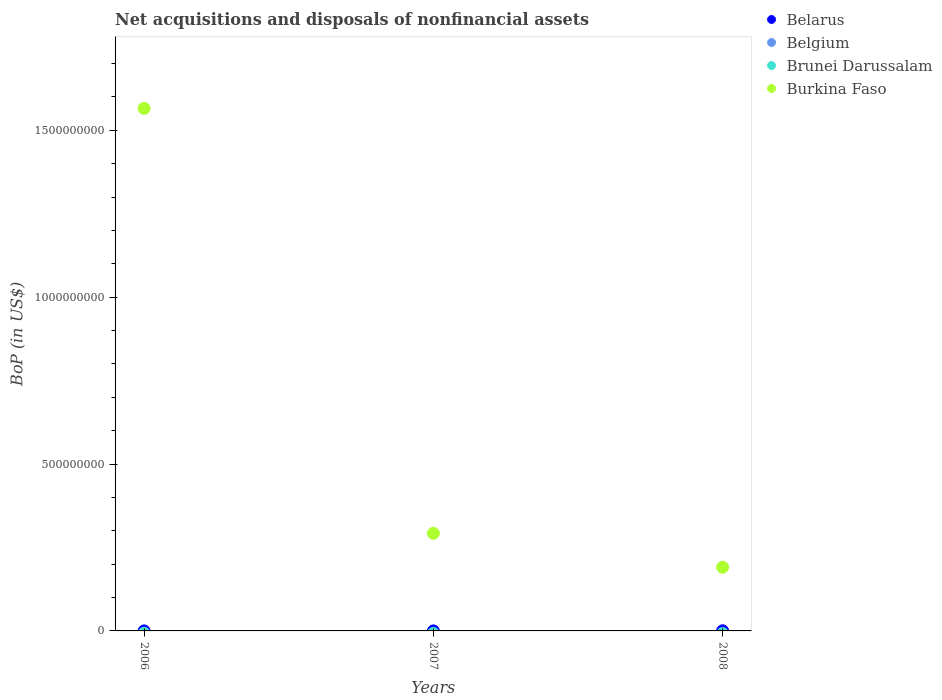Is the number of dotlines equal to the number of legend labels?
Provide a succinct answer. No. What is the Balance of Payments in Brunei Darussalam in 2008?
Your answer should be very brief. 0. Across all years, what is the maximum Balance of Payments in Burkina Faso?
Provide a succinct answer. 1.57e+09. What is the total Balance of Payments in Burkina Faso in the graph?
Your response must be concise. 2.05e+09. What is the difference between the Balance of Payments in Burkina Faso in 2007 and that in 2008?
Provide a succinct answer. 1.02e+08. What is the difference between the Balance of Payments in Burkina Faso in 2006 and the Balance of Payments in Belarus in 2007?
Give a very brief answer. 1.57e+09. What is the average Balance of Payments in Burkina Faso per year?
Ensure brevity in your answer.  6.83e+08. In the year 2006, what is the difference between the Balance of Payments in Burkina Faso and Balance of Payments in Belarus?
Offer a terse response. 1.57e+09. What is the ratio of the Balance of Payments in Belarus in 2006 to that in 2007?
Offer a terse response. 1. Is the Balance of Payments in Burkina Faso in 2006 less than that in 2007?
Provide a short and direct response. No. Is the difference between the Balance of Payments in Burkina Faso in 2006 and 2007 greater than the difference between the Balance of Payments in Belarus in 2006 and 2007?
Offer a terse response. Yes. What is the difference between the highest and the second highest Balance of Payments in Burkina Faso?
Offer a very short reply. 1.27e+09. What is the difference between the highest and the lowest Balance of Payments in Burkina Faso?
Make the answer very short. 1.37e+09. Does the Balance of Payments in Belgium monotonically increase over the years?
Your answer should be compact. No. Is the Balance of Payments in Belarus strictly less than the Balance of Payments in Belgium over the years?
Provide a short and direct response. No. Are the values on the major ticks of Y-axis written in scientific E-notation?
Your answer should be compact. No. Does the graph contain any zero values?
Ensure brevity in your answer.  Yes. Where does the legend appear in the graph?
Provide a succinct answer. Top right. What is the title of the graph?
Your answer should be compact. Net acquisitions and disposals of nonfinancial assets. Does "San Marino" appear as one of the legend labels in the graph?
Your answer should be compact. No. What is the label or title of the Y-axis?
Your answer should be compact. BoP (in US$). What is the BoP (in US$) of Belgium in 2006?
Your answer should be very brief. 0. What is the BoP (in US$) in Brunei Darussalam in 2006?
Give a very brief answer. 0. What is the BoP (in US$) of Burkina Faso in 2006?
Your response must be concise. 1.57e+09. What is the BoP (in US$) of Belgium in 2007?
Your answer should be very brief. 0. What is the BoP (in US$) of Burkina Faso in 2007?
Provide a succinct answer. 2.92e+08. What is the BoP (in US$) of Belgium in 2008?
Make the answer very short. 0. What is the BoP (in US$) of Brunei Darussalam in 2008?
Your answer should be compact. 0. What is the BoP (in US$) of Burkina Faso in 2008?
Keep it short and to the point. 1.91e+08. Across all years, what is the maximum BoP (in US$) of Burkina Faso?
Make the answer very short. 1.57e+09. Across all years, what is the minimum BoP (in US$) of Belarus?
Provide a succinct answer. 1.00e+05. Across all years, what is the minimum BoP (in US$) in Burkina Faso?
Provide a short and direct response. 1.91e+08. What is the total BoP (in US$) of Brunei Darussalam in the graph?
Provide a short and direct response. 0. What is the total BoP (in US$) in Burkina Faso in the graph?
Keep it short and to the point. 2.05e+09. What is the difference between the BoP (in US$) of Belarus in 2006 and that in 2007?
Your response must be concise. 0. What is the difference between the BoP (in US$) of Burkina Faso in 2006 and that in 2007?
Your response must be concise. 1.27e+09. What is the difference between the BoP (in US$) in Belarus in 2006 and that in 2008?
Make the answer very short. -4.00e+05. What is the difference between the BoP (in US$) in Burkina Faso in 2006 and that in 2008?
Offer a very short reply. 1.37e+09. What is the difference between the BoP (in US$) of Belarus in 2007 and that in 2008?
Your answer should be compact. -4.00e+05. What is the difference between the BoP (in US$) of Burkina Faso in 2007 and that in 2008?
Offer a terse response. 1.02e+08. What is the difference between the BoP (in US$) in Belarus in 2006 and the BoP (in US$) in Burkina Faso in 2007?
Offer a very short reply. -2.92e+08. What is the difference between the BoP (in US$) of Belarus in 2006 and the BoP (in US$) of Burkina Faso in 2008?
Ensure brevity in your answer.  -1.91e+08. What is the difference between the BoP (in US$) of Belarus in 2007 and the BoP (in US$) of Burkina Faso in 2008?
Your response must be concise. -1.91e+08. What is the average BoP (in US$) of Belarus per year?
Provide a succinct answer. 2.33e+05. What is the average BoP (in US$) of Belgium per year?
Keep it short and to the point. 0. What is the average BoP (in US$) in Burkina Faso per year?
Your response must be concise. 6.83e+08. In the year 2006, what is the difference between the BoP (in US$) in Belarus and BoP (in US$) in Burkina Faso?
Your response must be concise. -1.57e+09. In the year 2007, what is the difference between the BoP (in US$) of Belarus and BoP (in US$) of Burkina Faso?
Offer a very short reply. -2.92e+08. In the year 2008, what is the difference between the BoP (in US$) of Belarus and BoP (in US$) of Burkina Faso?
Keep it short and to the point. -1.90e+08. What is the ratio of the BoP (in US$) in Belarus in 2006 to that in 2007?
Give a very brief answer. 1. What is the ratio of the BoP (in US$) of Burkina Faso in 2006 to that in 2007?
Your response must be concise. 5.35. What is the ratio of the BoP (in US$) of Burkina Faso in 2006 to that in 2008?
Your answer should be very brief. 8.2. What is the ratio of the BoP (in US$) in Belarus in 2007 to that in 2008?
Make the answer very short. 0.2. What is the ratio of the BoP (in US$) in Burkina Faso in 2007 to that in 2008?
Give a very brief answer. 1.53. What is the difference between the highest and the second highest BoP (in US$) of Belarus?
Offer a very short reply. 4.00e+05. What is the difference between the highest and the second highest BoP (in US$) in Burkina Faso?
Provide a short and direct response. 1.27e+09. What is the difference between the highest and the lowest BoP (in US$) of Burkina Faso?
Provide a short and direct response. 1.37e+09. 